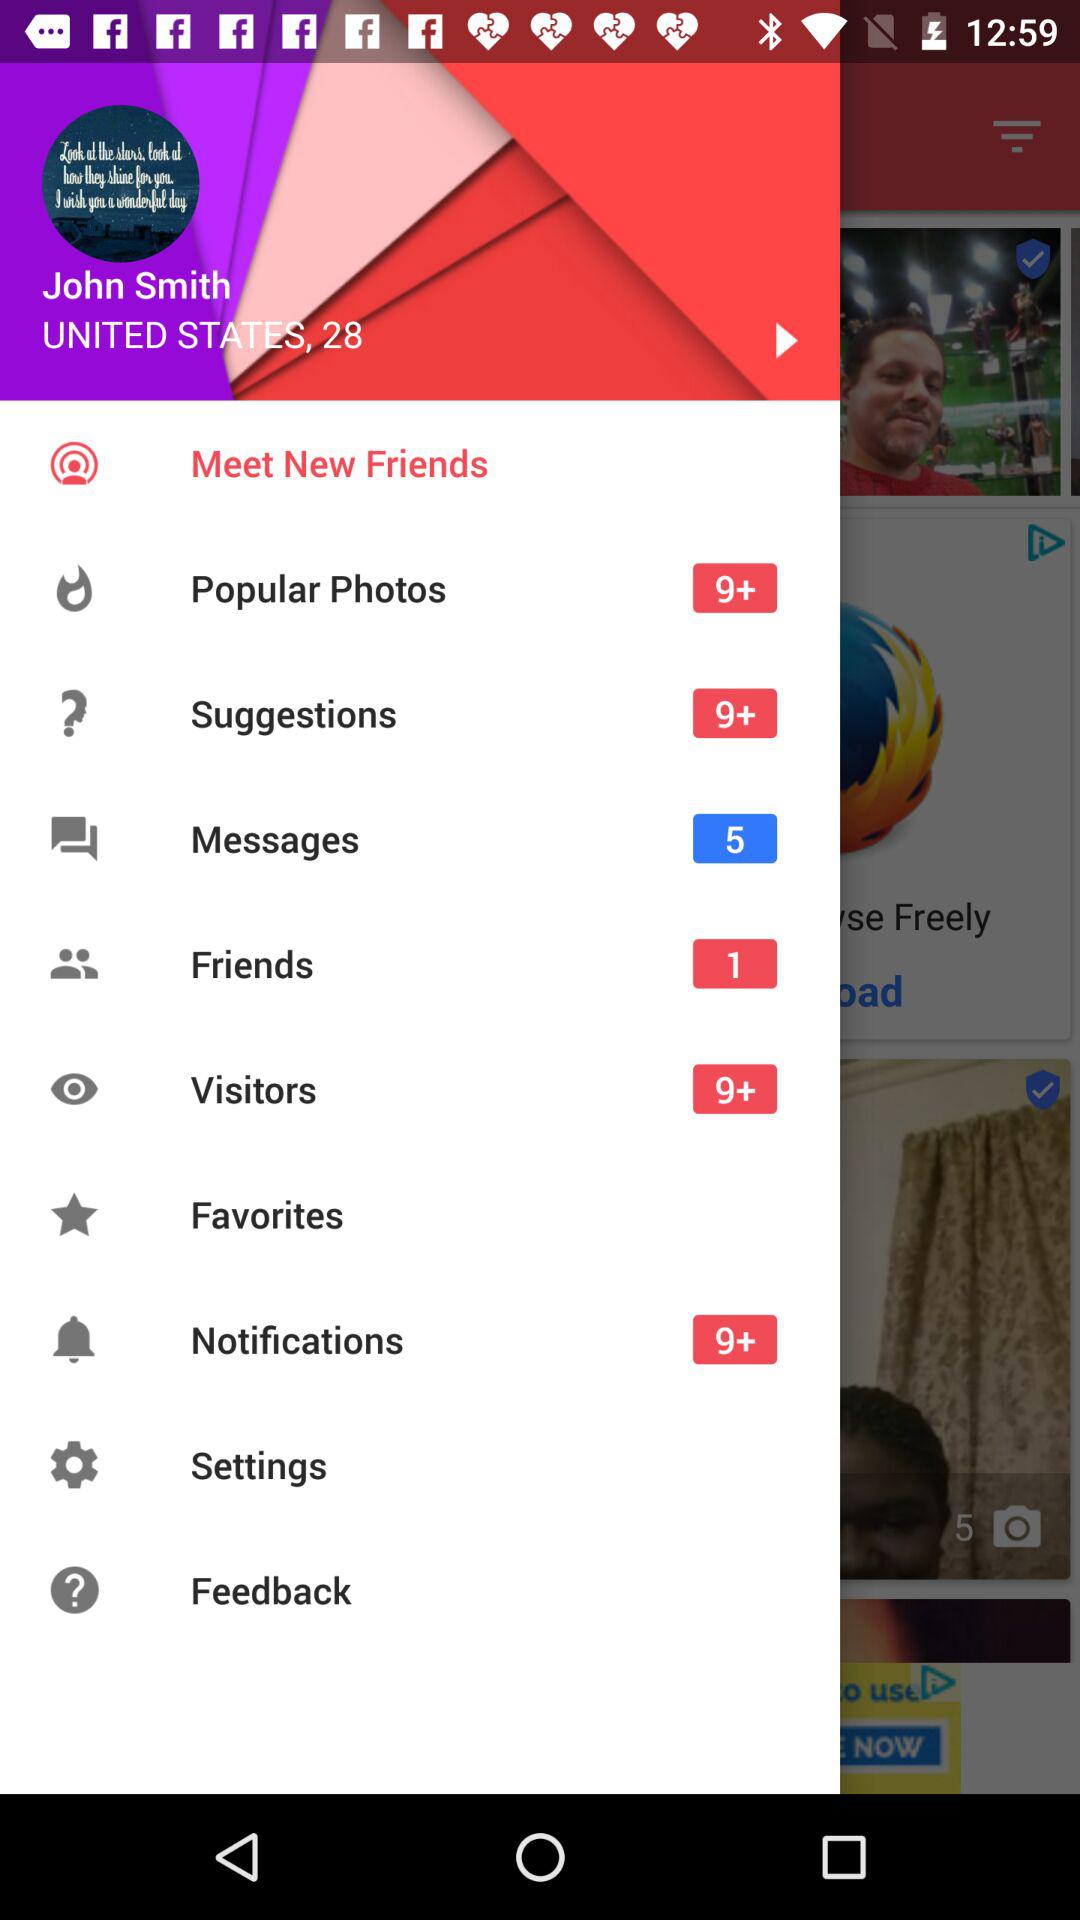What's the age of John Smith? John Smith is 28 years old. 